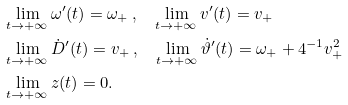Convert formula to latex. <formula><loc_0><loc_0><loc_500><loc_500>& \lim _ { t \to + \infty } \omega ^ { \prime } ( t ) = \omega _ { + } \, , \quad \lim _ { t \to + \infty } v ^ { \prime } ( t ) = v _ { + } \\ & \lim _ { t \to + \infty } \dot { D } ^ { \prime } ( t ) = v _ { + } \, , \quad \lim _ { t \to + \infty } \dot { \vartheta } ^ { \prime } ( t ) = \omega _ { + } + 4 ^ { - 1 } { v ^ { 2 } _ { + } } \\ & \lim _ { t \to + \infty } z ( t ) = 0 .</formula> 